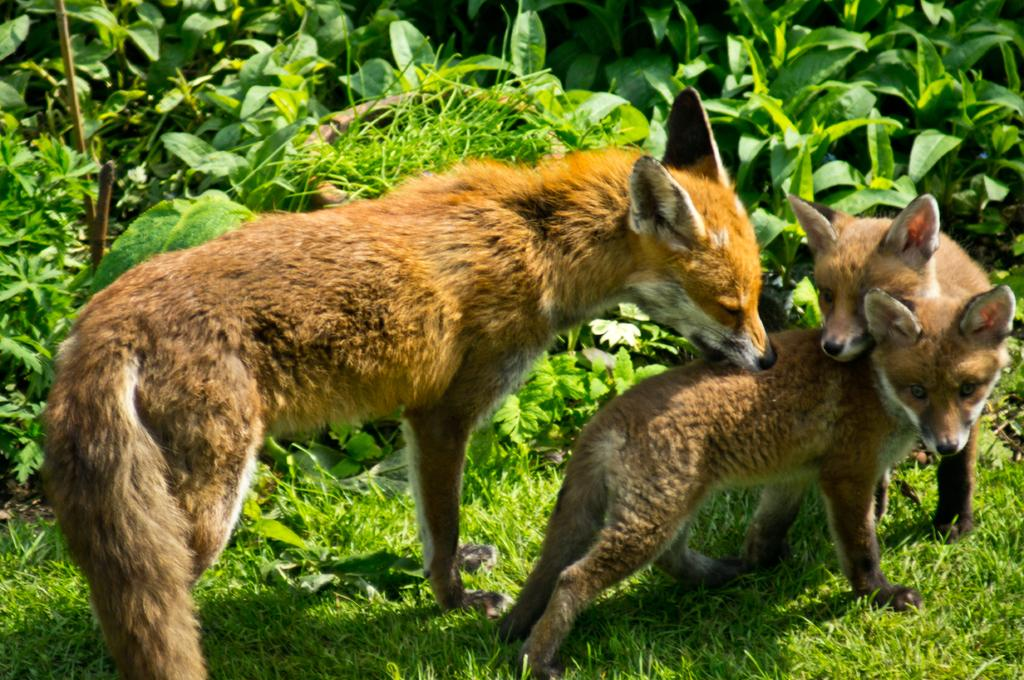What animals are present in the image? There are foxes in the image. What type of vegetation can be seen in the image? There are trees in the image. What is the ground covered with in the image? There is grass on the ground in the image. What is the tendency of the kettle in the image? There is no kettle present in the image. How many steps can be seen in the image? There are no steps visible in the image. 